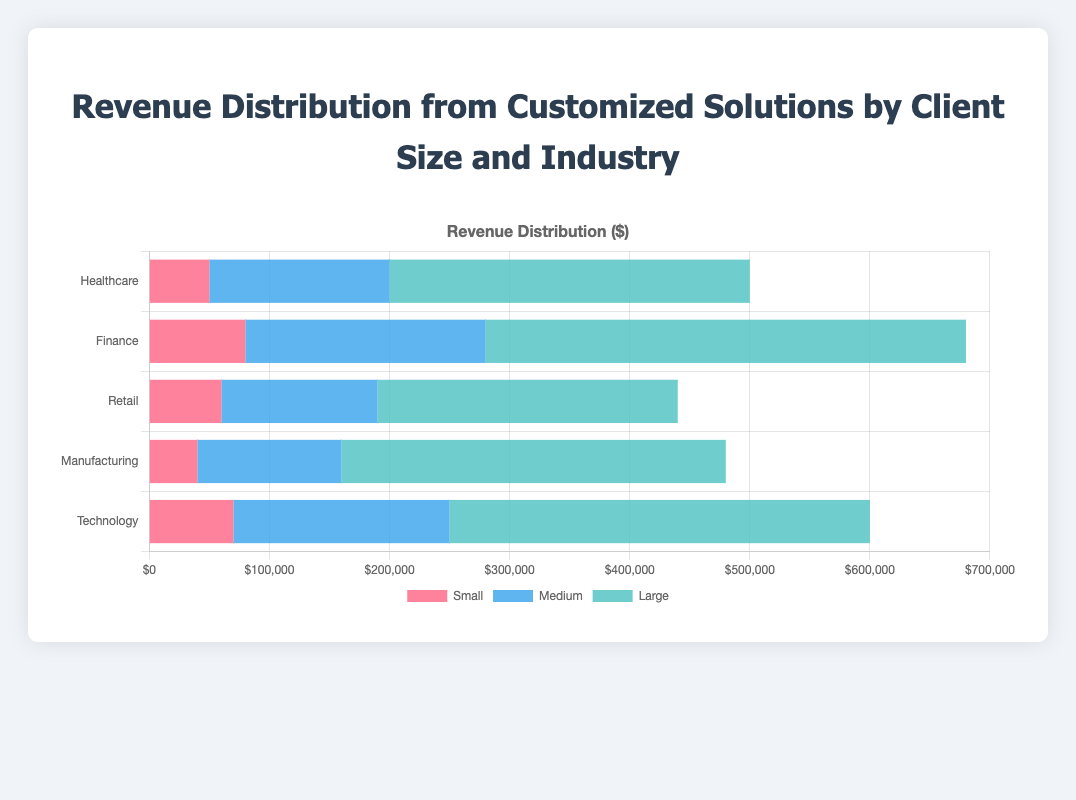What is the total revenue from small clients in the Technology industry? To find the total revenue from small clients in the Technology industry, refer to the bar representing the small clients in the Technology industry. The revenue value is $70,000.
Answer: $70,000 Which industry has the highest total revenue from large clients? Compare the revenue from large clients across all industries. The revenues are: Healthcare ($300,000), Finance ($400,000), Retail ($250,000), Manufacturing ($320,000), Technology ($350,000). Finance has the highest revenue from large clients.
Answer: Finance What is the combined revenue from large clients in the Healthcare and Technology industries? Add the revenue from large clients in the Healthcare industry ($300,000) to the revenue from large clients in the Technology industry ($350,000). The combined revenue is $300,000 + $350,000 = $650,000.
Answer: $650,000 How much more revenue do medium clients generate than small clients in the Finance industry? Subtract the revenue from small clients in the Finance industry ($80,000) from the revenue from medium clients in the same industry ($200,000). The difference is $200,000 - $80,000 = $120,000.
Answer: $120,000 Which industry has the smallest total revenue from their medium clients? Compare the revenue from medium clients across all industries. The revenues are: Healthcare ($150,000), Finance ($200,000), Retail ($130,000), Manufacturing ($120,000), Technology ($180,000). Manufacturing has the smallest revenue from medium clients.
Answer: Manufacturing What is the total revenue from all clients in the Retail industry? Add the revenues from small, medium, and large clients in the Retail industry. The total revenue is $60,000 (Small) + $130,000 (Medium) + $250,000 (Large) = $440,000.
Answer: $440,000 Which industry has the longest bar for large clients, and what does this indicate visually? The Finance industry has the longest bar for large clients, indicating that it generates the highest revenue from large clients compared to other industries.
Answer: Finance, highest large client revenue Among all industries, which type of client contributes the most to the total revenue and in which industry? Compare the contributions across all industries and client sizes. The Finance industry has the highest contribution from large clients with $400,000.
Answer: Large clients, Finance What is the average revenue generated by medium clients across all industries? Sum the revenues from medium clients across all industries and divide by the number of industries. The total revenue is $150,000 (Healthcare) + $200,000 (Finance) + $130,000 (Retail) + $120,000 (Manufacturing) + $180,000 (Technology) = $780,000. The average revenue is $780,000 / 5 = $156,000.
Answer: $156,000 